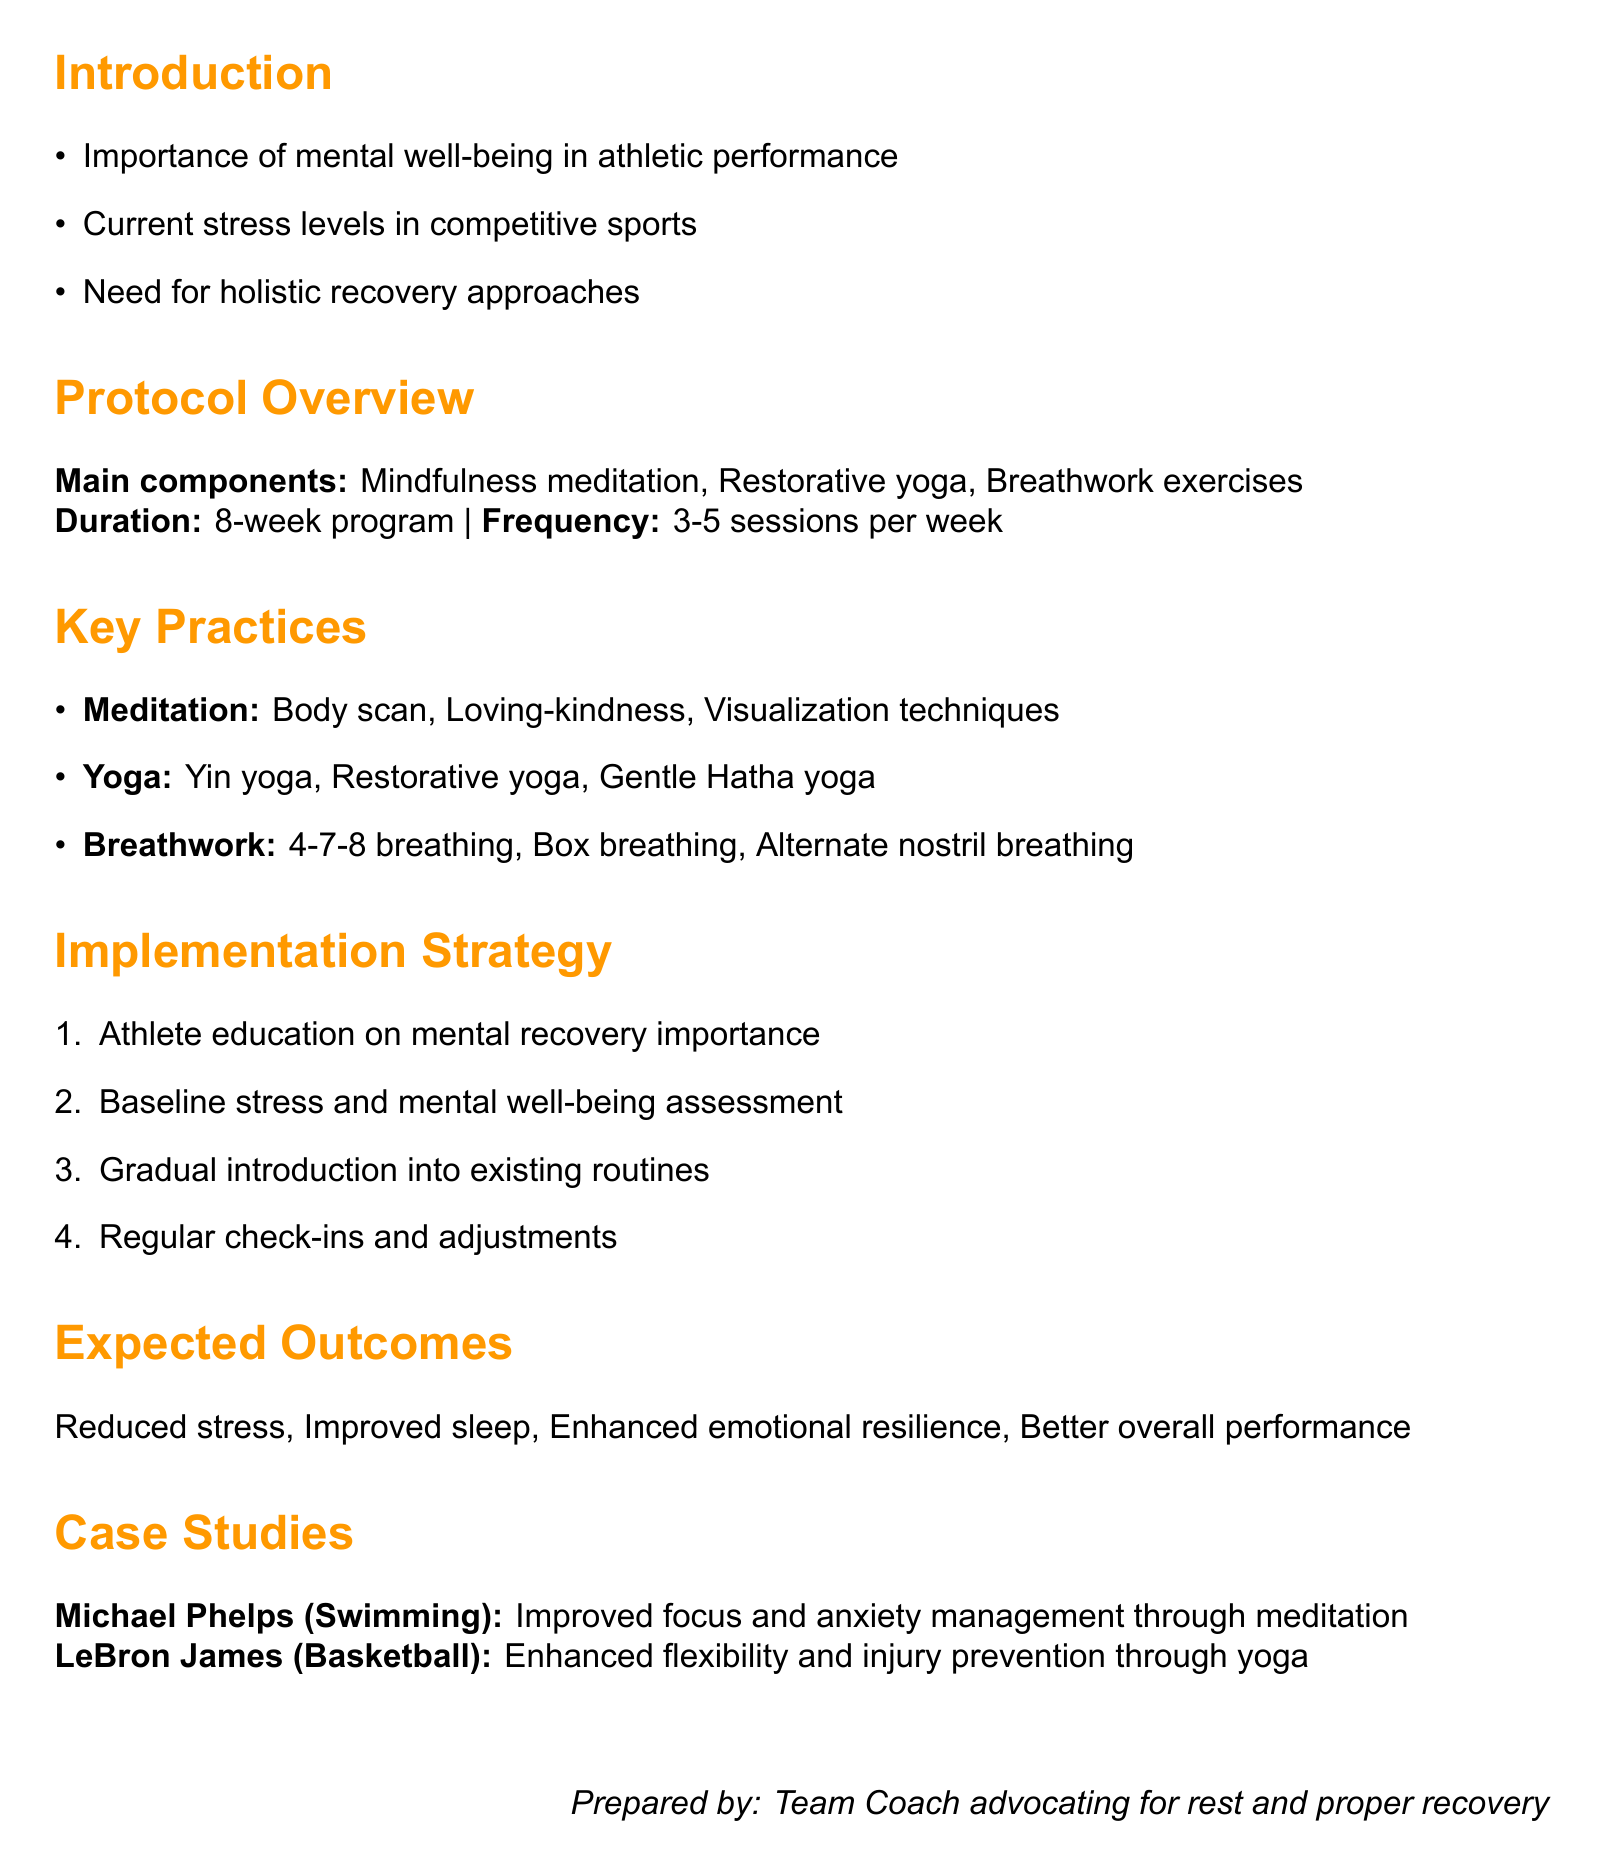What is the title of the memo? The title is directly stated at the beginning of the document.
Answer: New Recovery Protocol: Integrating Meditation and Yoga for Athlete Well-being How long is the recovery program? The duration of the program is specified in the overview section.
Answer: 8-week program What are the recommended apps for meditation? The document lists apps that can be used for meditation in a specific section.
Answer: Headspace for Sport, Calm, Insight Timer What type of yoga is included in the protocol? The specific styles of yoga included in the protocol are mentioned in the yoga practices section.
Answer: Yin yoga, Restorative yoga, Gentle Hatha yoga What is a potential challenge mentioned for implementation? The document provides specific challenges in the section about potential challenges.
Answer: Athlete buy-in and consistency What is one expected outcome of the new recovery protocol? The expected outcomes are listed at the end of the protocol overview.
Answer: Reduced perceived stress levels Who is one of the key personnel involved in the implementation strategy? The key personnel are mentioned in the implementation strategy section of the document.
Answer: Team psychologist Which athlete is mentioned as a case study? The document includes notable athletes as case studies in a specific section.
Answer: Michael Phelps, LeBron James What is one meditation practice included in the protocol? The document describes different types of meditation practices in the meditation section.
Answer: Body scan meditation 